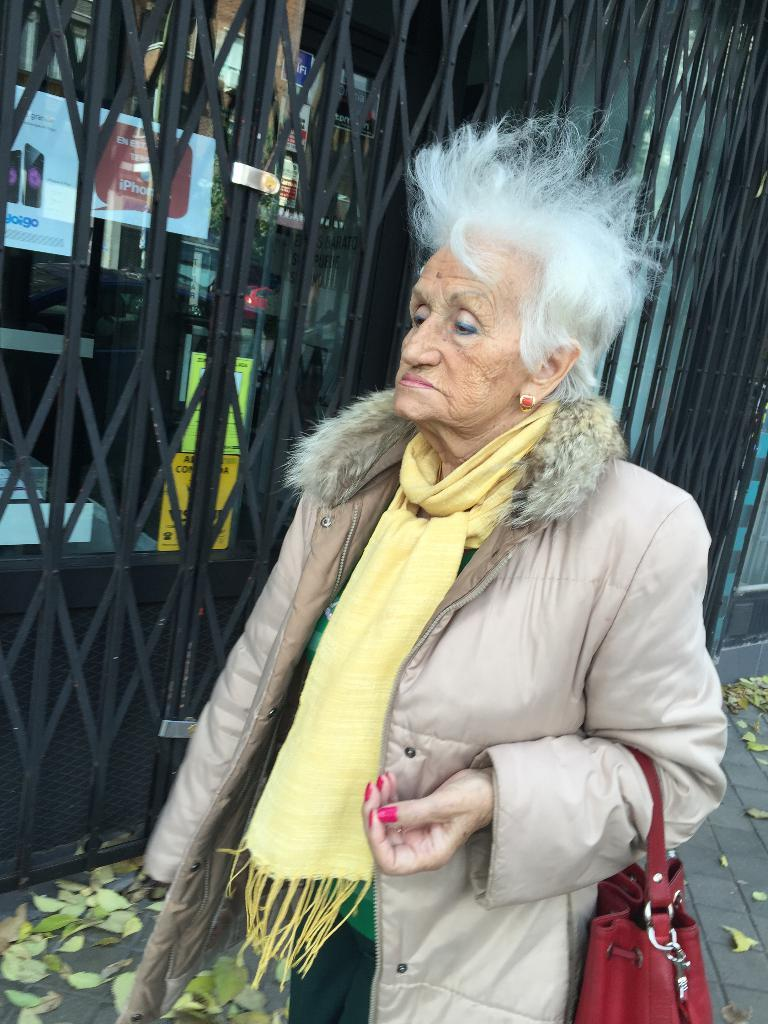Who is the main subject in the image? There is an old woman in the image. What is the old woman holding in her hand? The old woman is holding a bag in her hand. What is the old woman doing in the image? The old woman is walking on the road. What can be seen in the background of the image? There is a door visible in the background of the image. How many icicles are hanging from the old woman's clothing in the image? There are no icicles present in the image. What type of sail is visible on the old woman's hat in the image? There is no sail present in the image, nor is there a hat visible on the old woman. 